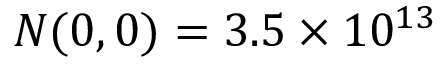<formula> <loc_0><loc_0><loc_500><loc_500>N ( 0 , 0 ) = 3 . 5 \times 1 0 ^ { 1 3 }</formula> 